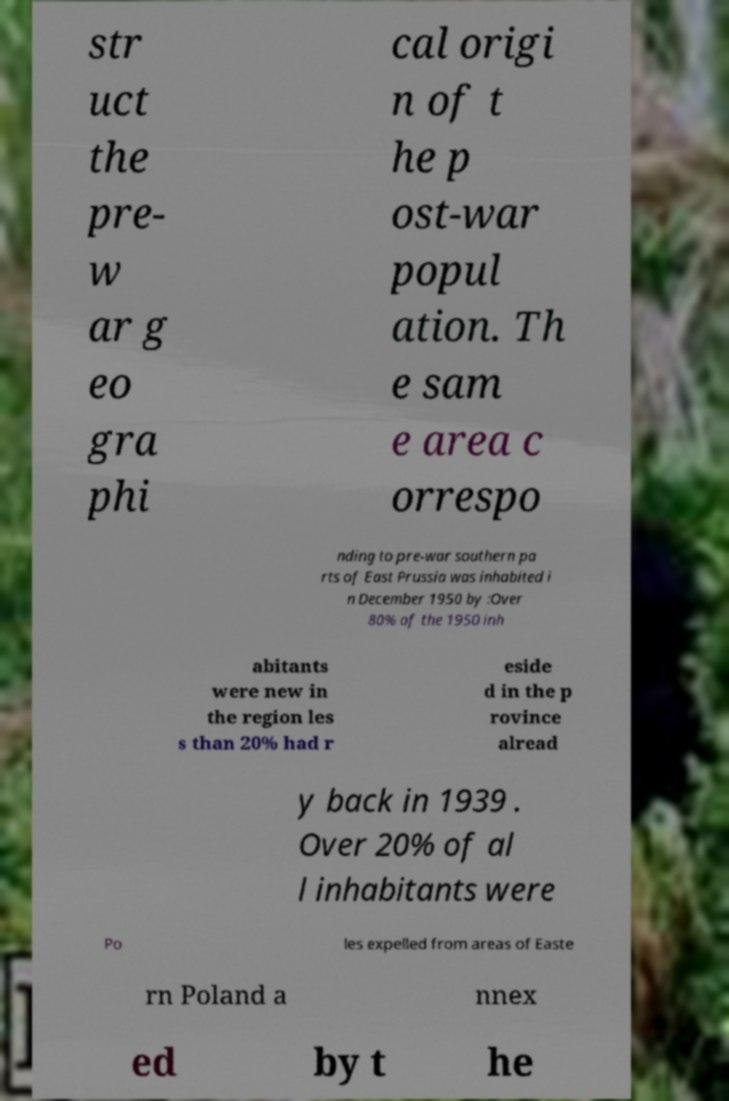Please read and relay the text visible in this image. What does it say? str uct the pre- w ar g eo gra phi cal origi n of t he p ost-war popul ation. Th e sam e area c orrespo nding to pre-war southern pa rts of East Prussia was inhabited i n December 1950 by :Over 80% of the 1950 inh abitants were new in the region les s than 20% had r eside d in the p rovince alread y back in 1939 . Over 20% of al l inhabitants were Po les expelled from areas of Easte rn Poland a nnex ed by t he 